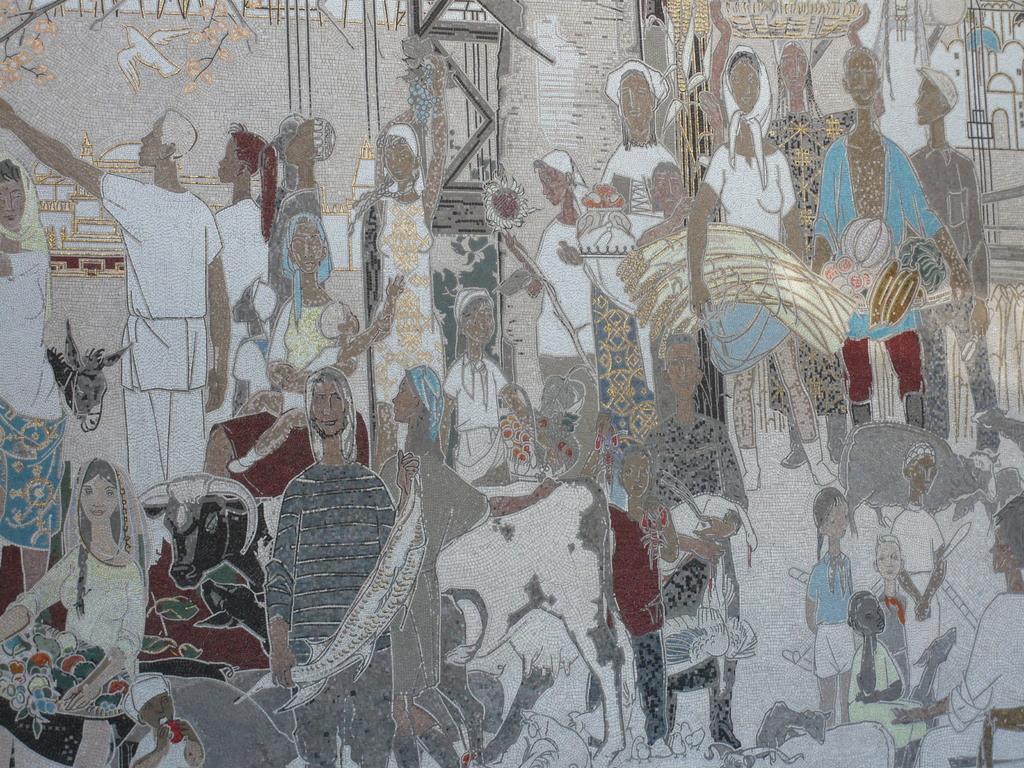Can you describe this image briefly? In this image we can see the drawing of a group of people. Here we can see a bird flying on the top left side. Here we can see the animals. Here we can see a woman on the bottom left side is selling the fruits. Here we can see a donkey on the left side. 